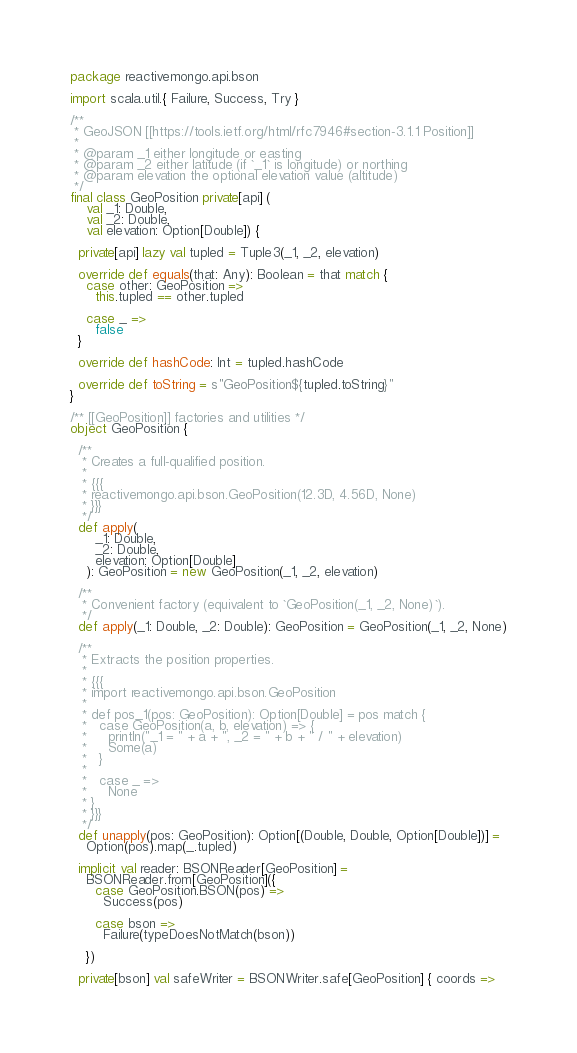<code> <loc_0><loc_0><loc_500><loc_500><_Scala_>package reactivemongo.api.bson

import scala.util.{ Failure, Success, Try }

/**
 * GeoJSON [[https://tools.ietf.org/html/rfc7946#section-3.1.1 Position]]
 *
 * @param _1 either longitude or easting
 * @param _2 either latitude (if `_1` is longitude) or northing
 * @param elevation the optional elevation value (altitude)
 */
final class GeoPosition private[api] (
    val _1: Double,
    val _2: Double,
    val elevation: Option[Double]) {

  private[api] lazy val tupled = Tuple3(_1, _2, elevation)

  override def equals(that: Any): Boolean = that match {
    case other: GeoPosition =>
      this.tupled == other.tupled

    case _ =>
      false
  }

  override def hashCode: Int = tupled.hashCode

  override def toString = s"GeoPosition${tupled.toString}"
}

/** [[GeoPosition]] factories and utilities */
object GeoPosition {

  /**
   * Creates a full-qualified position.
   *
   * {{{
   * reactivemongo.api.bson.GeoPosition(12.3D, 4.56D, None)
   * }}}
   */
  def apply(
      _1: Double,
      _2: Double,
      elevation: Option[Double]
    ): GeoPosition = new GeoPosition(_1, _2, elevation)

  /**
   * Convenient factory (equivalent to `GeoPosition(_1, _2, None)`).
   */
  def apply(_1: Double, _2: Double): GeoPosition = GeoPosition(_1, _2, None)

  /**
   * Extracts the position properties.
   *
   * {{{
   * import reactivemongo.api.bson.GeoPosition
   *
   * def pos_1(pos: GeoPosition): Option[Double] = pos match {
   *   case GeoPosition(a, b, elevation) => {
   *     println("_1 = " + a + ", _2 = " + b + " / " + elevation)
   *     Some(a)
   *   }
   *
   *   case _ =>
   *     None
   * }
   * }}}
   */
  def unapply(pos: GeoPosition): Option[(Double, Double, Option[Double])] =
    Option(pos).map(_.tupled)

  implicit val reader: BSONReader[GeoPosition] =
    BSONReader.from[GeoPosition]({
      case GeoPosition.BSON(pos) =>
        Success(pos)

      case bson =>
        Failure(typeDoesNotMatch(bson))

    })

  private[bson] val safeWriter = BSONWriter.safe[GeoPosition] { coords =></code> 